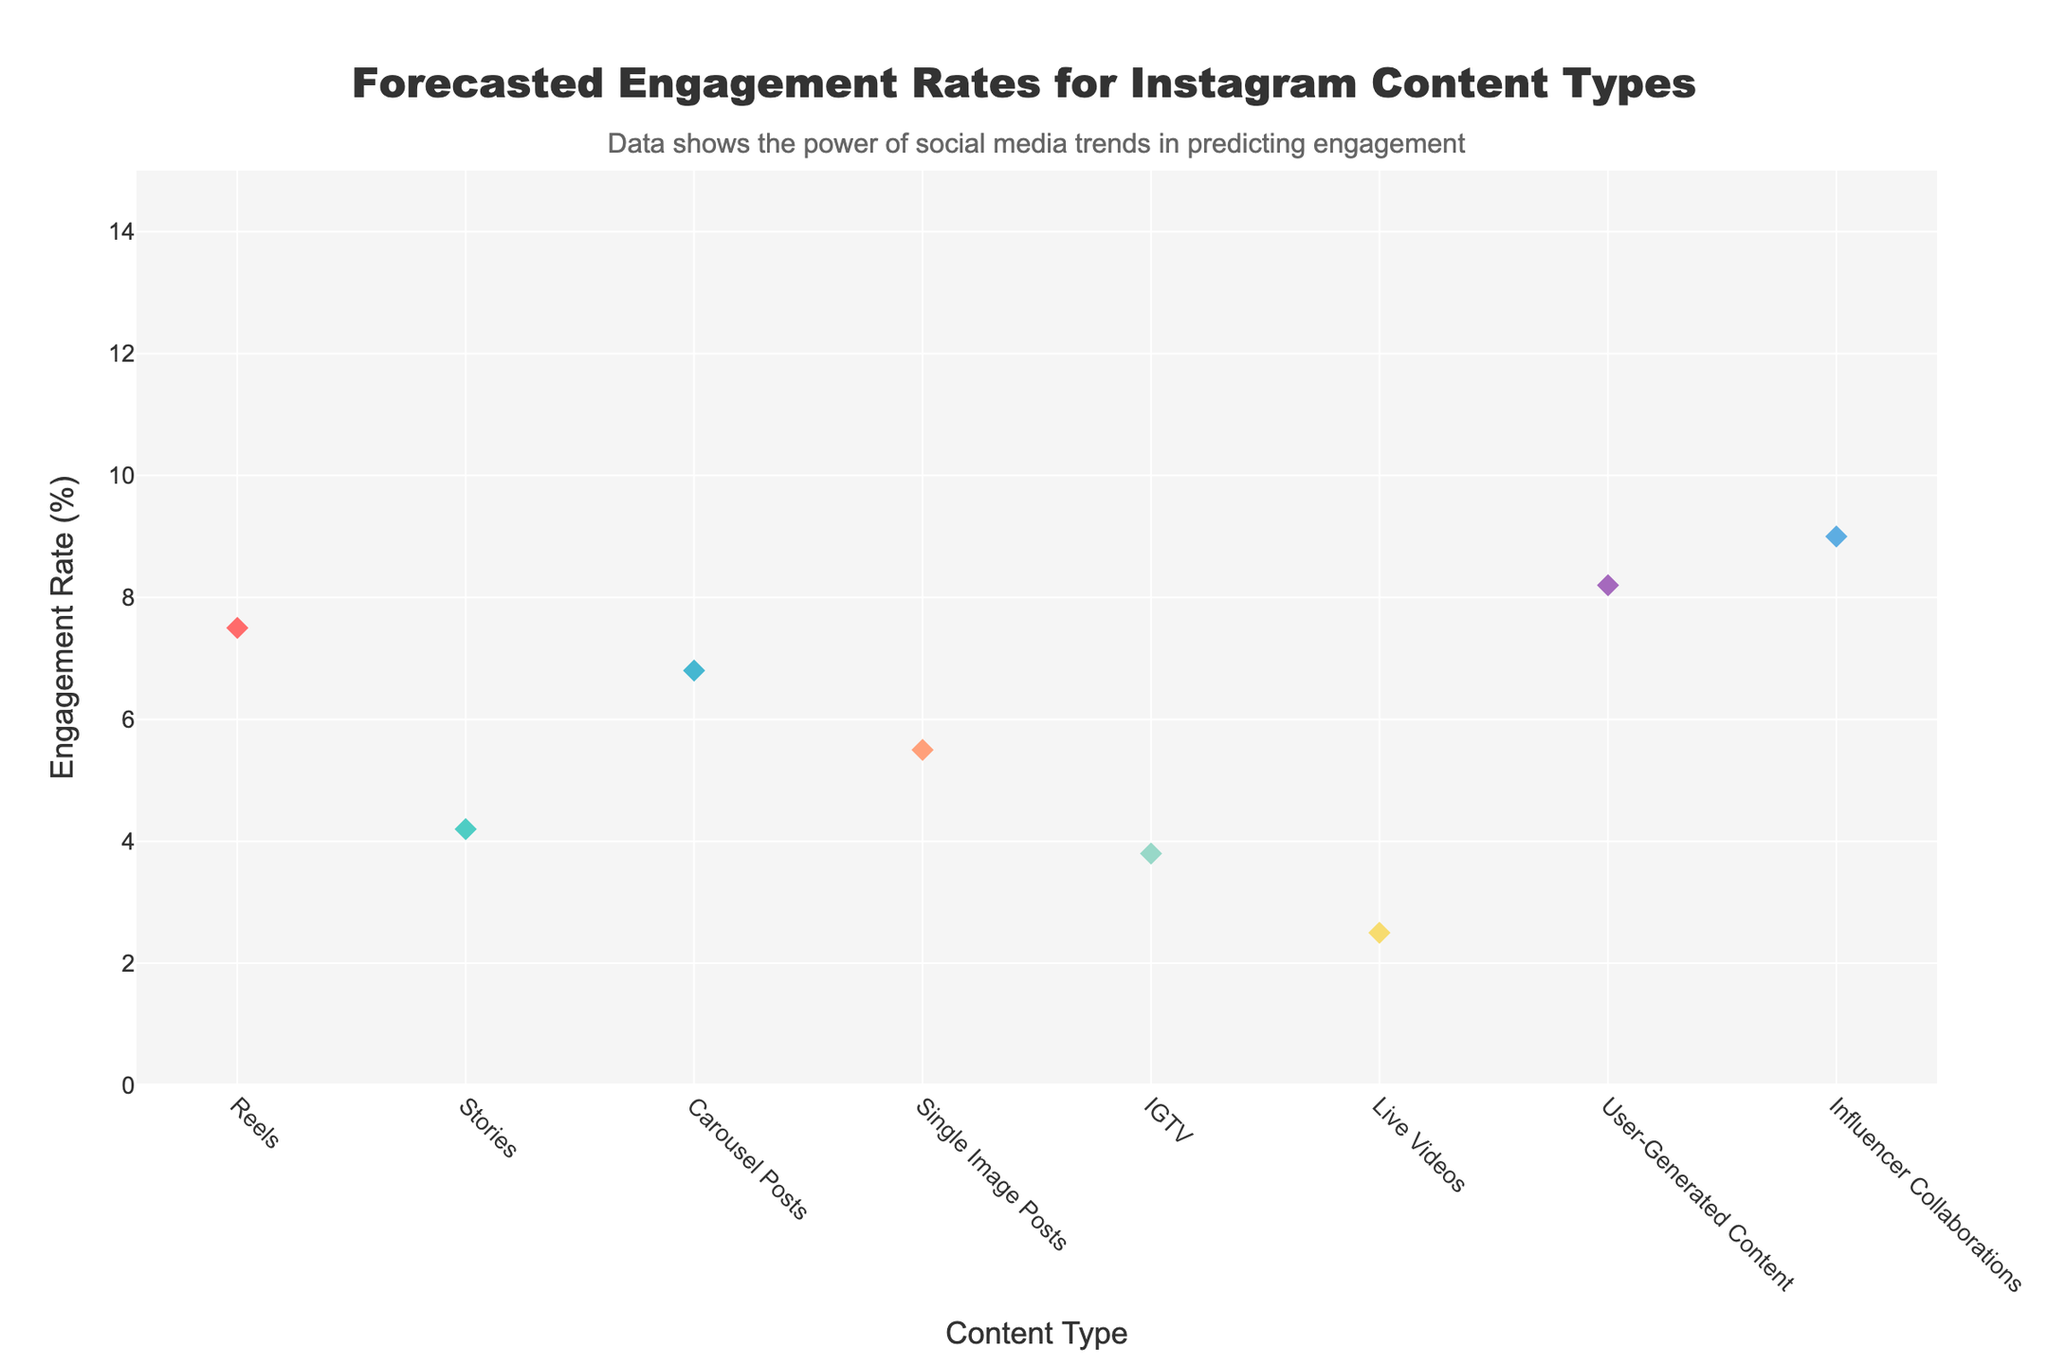What is the median engagement rate for Reels? The median engagement rate is indicated by a diamond marker on the line for Reels. According to the figure, the median engagement rate for Reels is found where this marker is placed.
Answer: 7.5% Which content type has the lowest 10th percentile engagement rate? To find the content type with the lowest 10th percentile engagement rate, look at the bottom points of each filled area on the chart. The lowest point corresponds to Live Videos.
Answer: Live Videos What is the range of engagement rates for Carousels between the 25th and 75th percentiles? The 25th percentile engagement rate for Carousel Posts is at 5.2%, and the 75th percentile is at 8.5%. The range is the difference between these two values: 8.5% - 5.2% = 3.3%.
Answer: 3.3% Which content type has the highest median engagement rate? To determine the highest median engagement rate, compare the diamond markers corresponding to medians. Influencer Collaborations has the highest median engagement rate.
Answer: Influencer Collaborations How does the 90th percentile engagement rate for Stories compare to that of Reels? The 90th percentile engagement rate for Stories is 7.0%, and for Reels, it is 11.7%. To compare, note that 7.0% is less than 11.7%.
Answer: Stories' 90th percentile is lower than Reels' How much higher is the median engagement rate for Influencer Collaborations compared to IGTV? The median engagement rate for Influencer Collaborations is 9.0%, and for IGTV, it is 3.8%. The difference is 9.0% - 3.8% = 5.2%.
Answer: 5.2% What is the interquartile range (IQR) for User-Generated Content? The IQR is calculated as the difference between the 75th percentile and the 25th percentile. For User-Generated Content, the 75th percentile is 10.2% and the 25th percentile is 6.3%. Thus, the IQR is 10.2% - 6.3% = 3.9%.
Answer: 3.9% Which content type has the largest spread between the 10th and 90th percentiles? To find the largest spread, calculate the difference between the 10th and 90th percentiles for each content type. The largest difference is for Influencer Collaborations: 14.0% - 5.3% = 8.7%.
Answer: Influencer Collaborations How many distinct content types are shown in the chart? Count the number of unique content types listed on the x-axis in the chart. There are eight distinct content types.
Answer: 8 What is the engagement rate at the 75th percentile for Single Image Posts? The engagement rate at the 75th percentile for Single Image Posts is where the line hits the upper boundary of the filled area. According to the chart, it is 7.0%.
Answer: 7.0% 